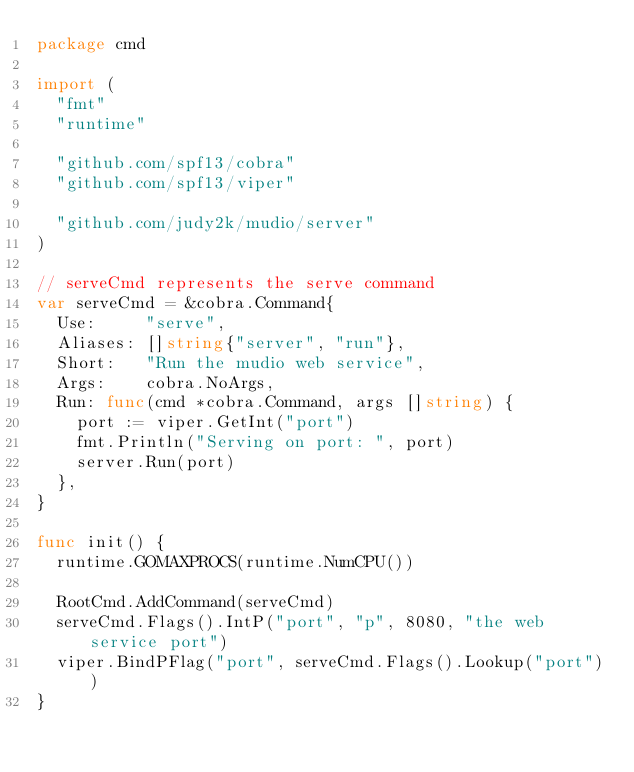<code> <loc_0><loc_0><loc_500><loc_500><_Go_>package cmd

import (
	"fmt"
	"runtime"

	"github.com/spf13/cobra"
	"github.com/spf13/viper"

	"github.com/judy2k/mudio/server"
)

// serveCmd represents the serve command
var serveCmd = &cobra.Command{
	Use:     "serve",
	Aliases: []string{"server", "run"},
	Short:   "Run the mudio web service",
	Args:    cobra.NoArgs,
	Run: func(cmd *cobra.Command, args []string) {
		port := viper.GetInt("port")
		fmt.Println("Serving on port: ", port)
		server.Run(port)
	},
}

func init() {
	runtime.GOMAXPROCS(runtime.NumCPU())

	RootCmd.AddCommand(serveCmd)
	serveCmd.Flags().IntP("port", "p", 8080, "the web service port")
	viper.BindPFlag("port", serveCmd.Flags().Lookup("port"))
}
</code> 